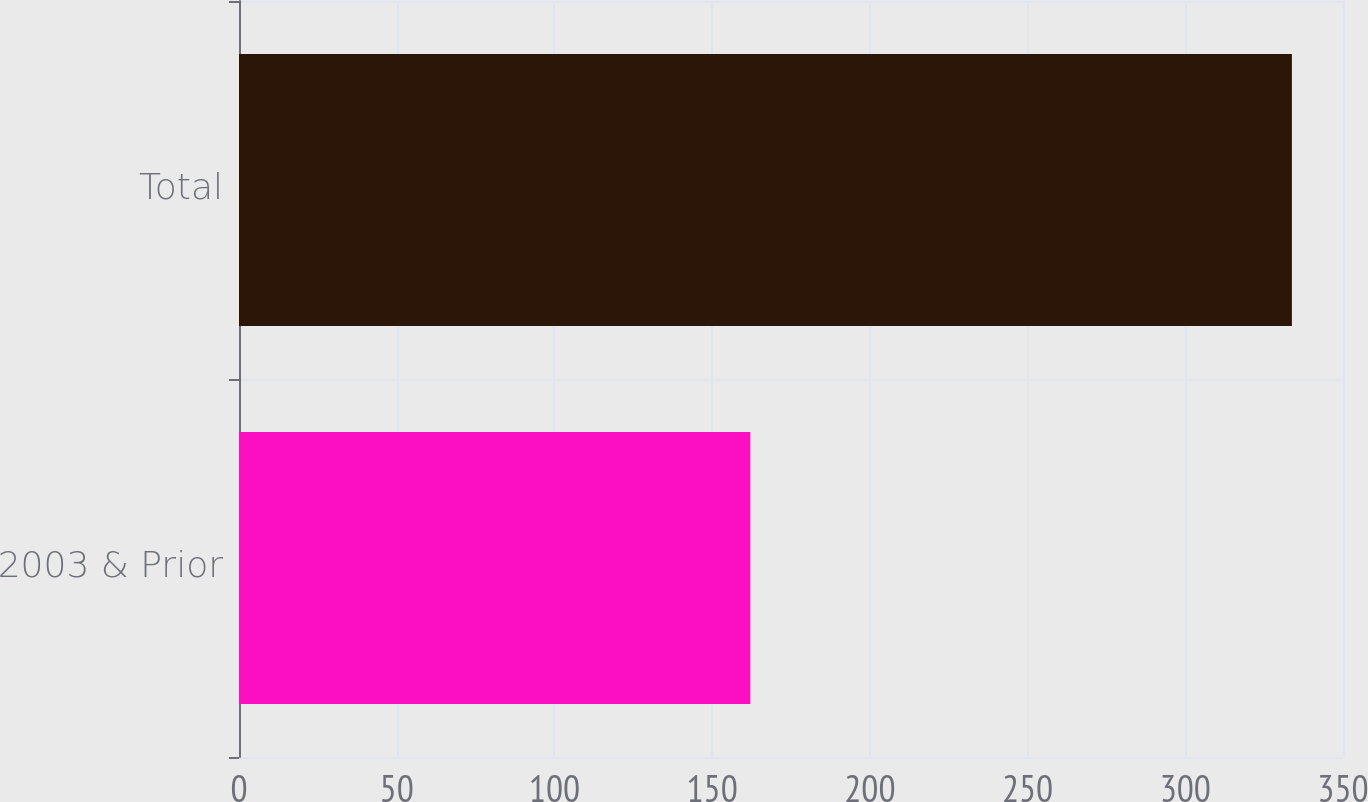Convert chart. <chart><loc_0><loc_0><loc_500><loc_500><bar_chart><fcel>2003 & Prior<fcel>Total<nl><fcel>162.1<fcel>333.8<nl></chart> 